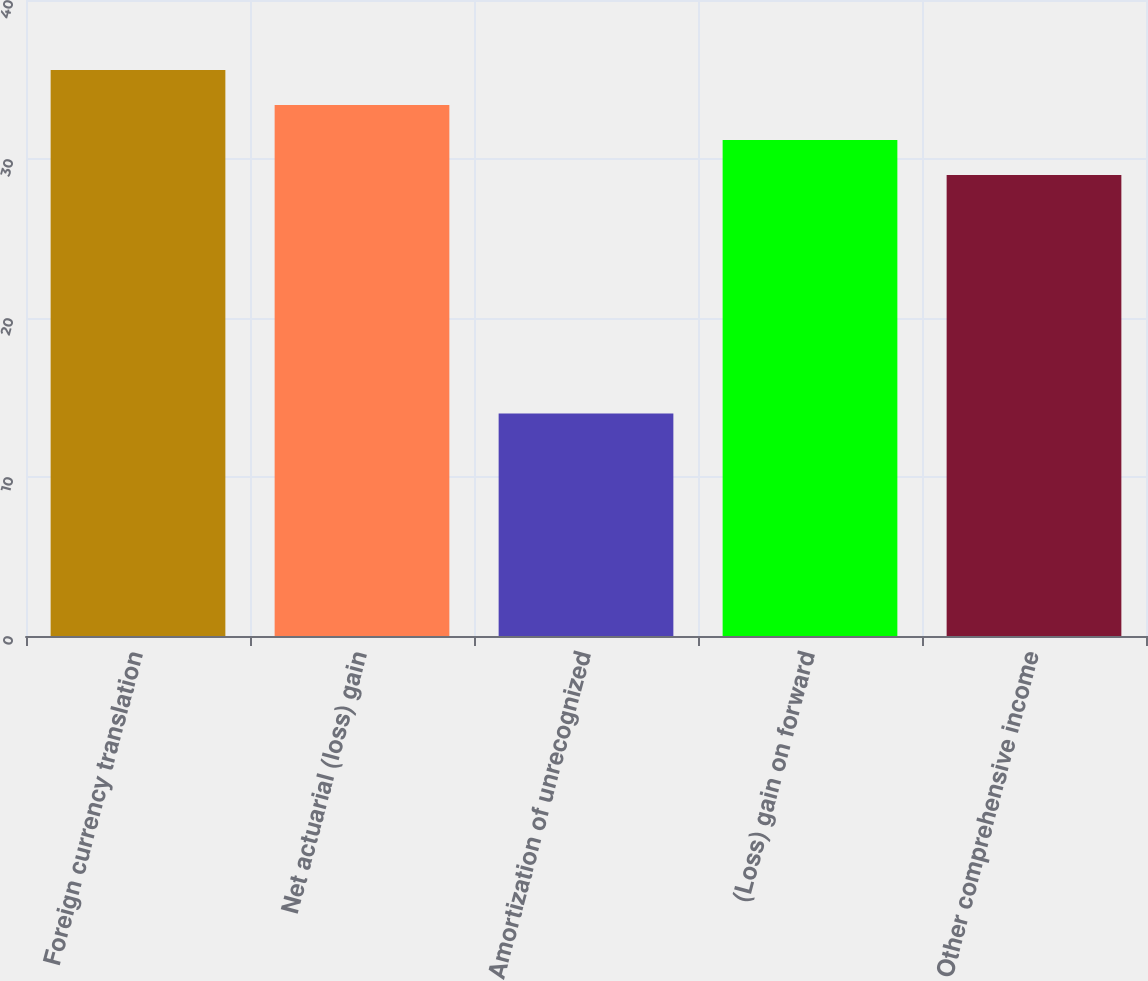Convert chart. <chart><loc_0><loc_0><loc_500><loc_500><bar_chart><fcel>Foreign currency translation<fcel>Net actuarial (loss) gain<fcel>Amortization of unrecognized<fcel>(Loss) gain on forward<fcel>Other comprehensive income<nl><fcel>35.6<fcel>33.4<fcel>14<fcel>31.2<fcel>29<nl></chart> 